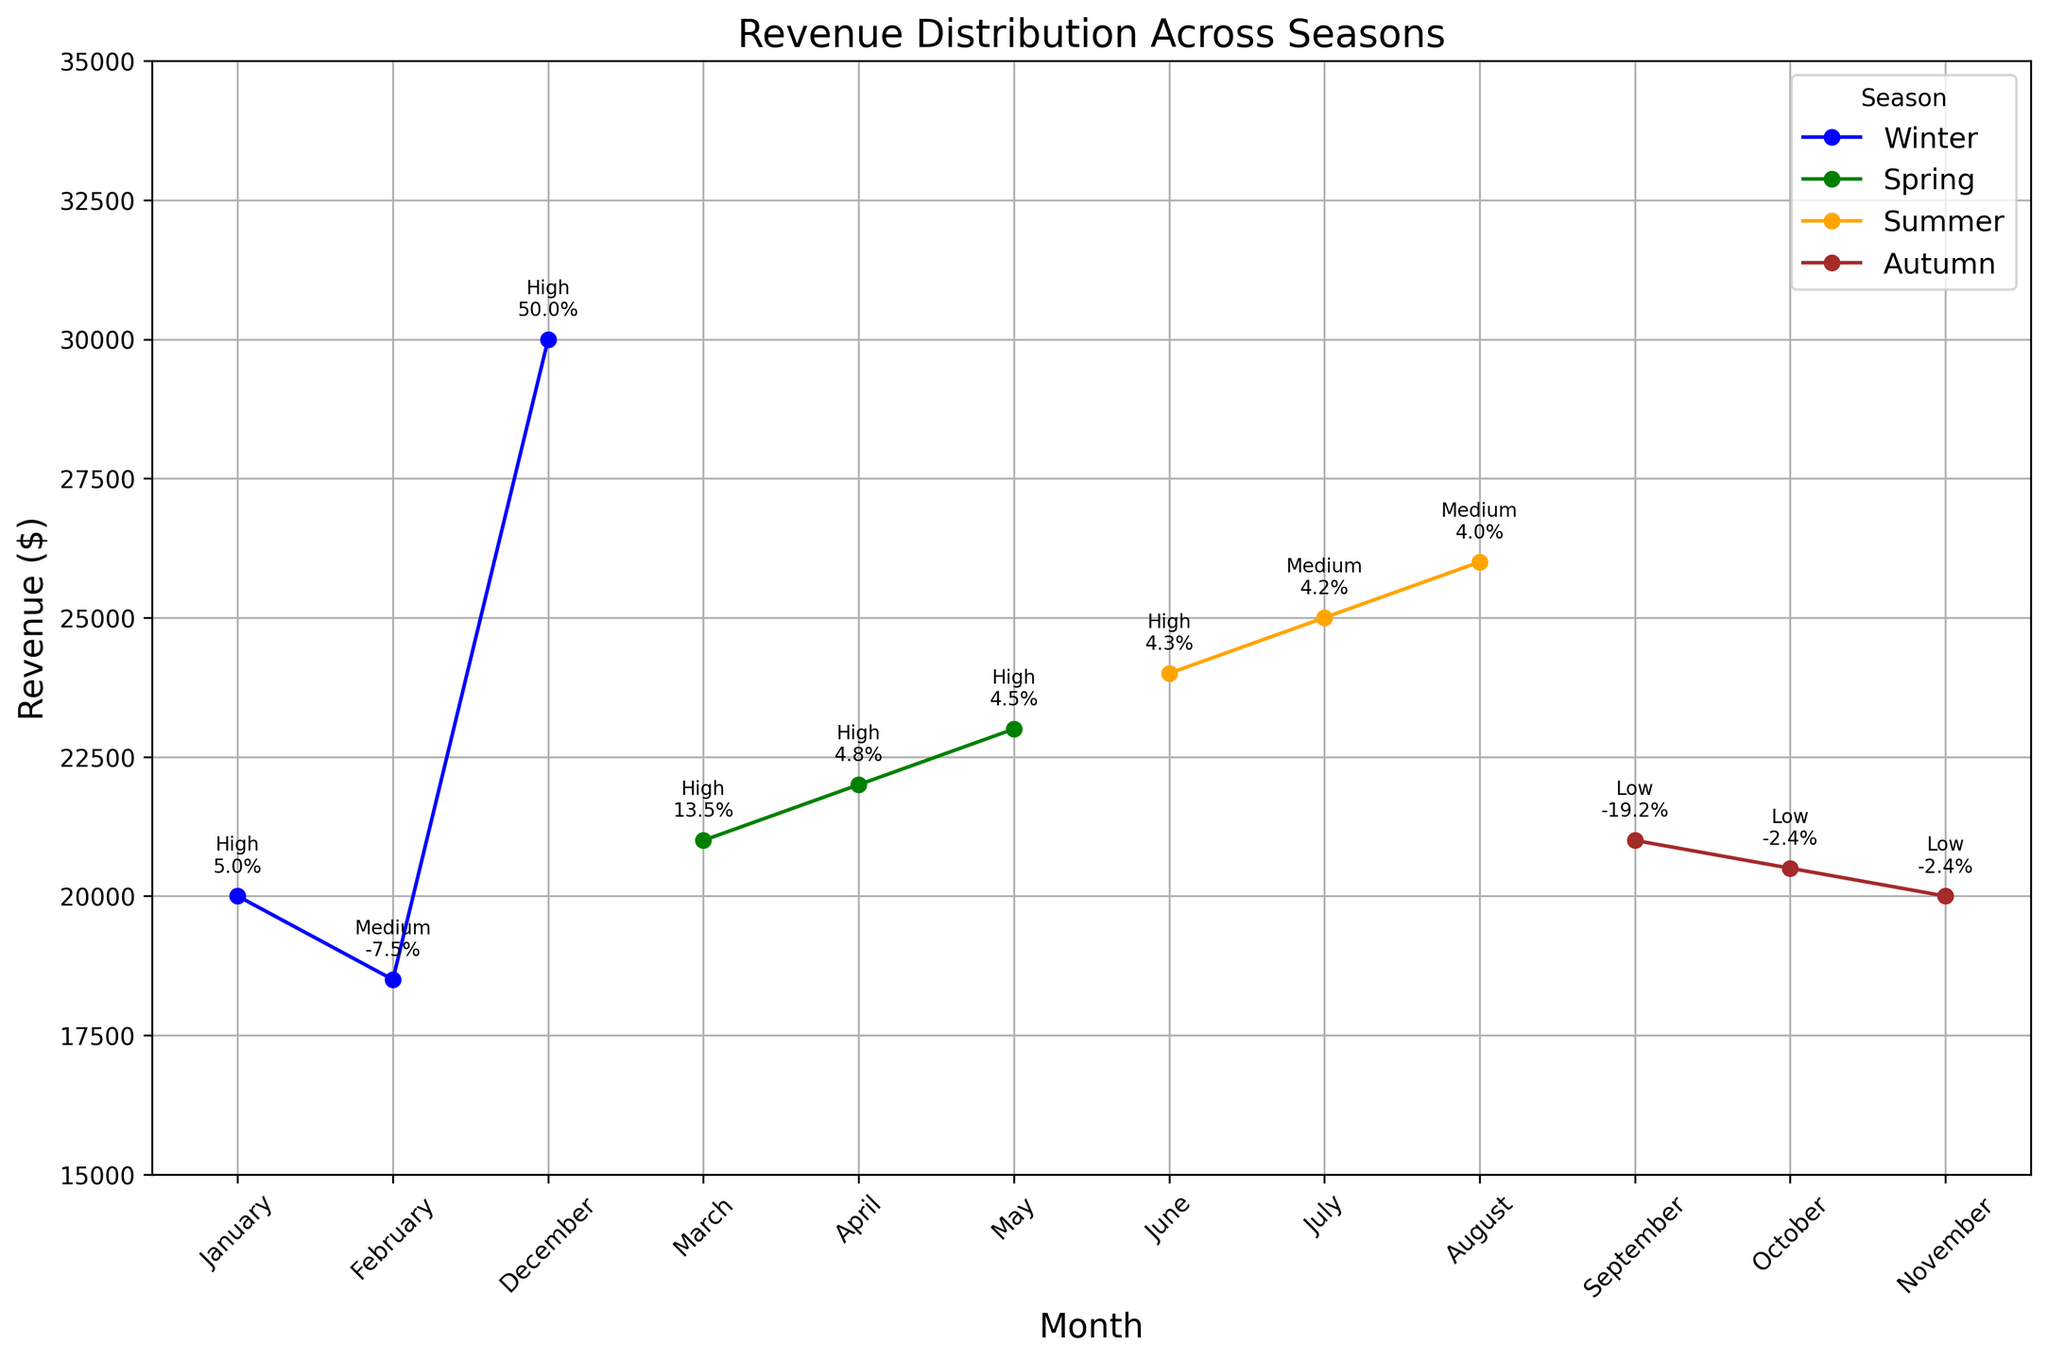What's the highest revenue recorded in any season? The highest revenue value can be found by looking at the peak of the plot. Refer to the annotations and read through the revenue values marked for each month. In December (Winter), the highest revenue of $30,000 is recorded.
Answer: $30,000 Which month experienced the highest revenue variation percentage? Check the variation percentages annotated on the plot for each month. The highest percentage of variation is in December which has a variation of 50%.
Answer: December During which season did the revenue decline the most compared to the previous month, and by how much? Identify the months with negative variation percentages and compare the absolute values to determine the largest decline. In Autumn, between August and September, the revenue dropped from $26,000 to $21,000 which is a decline of $5,000.
Answer: Autumn, $5,000 In which months were promotional campaigns most successful, and during which seasons do they occur? Look at the text annotations for "High" campaign success and note the corresponding months and seasons. Promotional campaigns were "High" in January, March, April, May, June, and December, which are in Winter, Spring, and Summer respectively.
Answer: Winter, Spring, Summer Compare the lowest revenue of Winter and Autumn. Which season recorded lower revenue and by how much? Identify the lowest revenue value in Winter and Autumn by checking the revenue values for those months. For Winter, the lowest revenue is $18,500 in February. For Autumn, the lowest is $20,000 in November. The difference is $20,000 - $18,500 = $1,500, with Winter being lower.
Answer: Winter, $1,500 How did the revenue vary across consecutive months in Autumn? Check the revenue values for September, October, and November in Autumn and observe the changes. Revenue in September is $21,000, in October it is $20,500, and in November it is $20,000. The revenue decreases each consecutive month.
Answer: Decreased consecutively Calculate the average revenue for each season and determine which season had the highest average. Sum the revenue values for each season and divide by the number of months in that season. For Winter: (20000+18500+30000)/3 = 22833.33; for Spring: (21000+22000+23000)/3 = 22000; for Summer (24000+25000+26000)/3 = 25000; for Autumn: (21000+20500+20000)/3 = 20500. The highest average revenue is in Summer.
Answer: Summer Which month within Spring had the lowest revenue variation percentage and what is that percentage? Look at the variation percentage annotations for March, April, and May. The lowest variation percentage in Spring is for May, with a percentage of 4.5%.
Answer: May, 4.5% Among months with "Low" campaign success, which month had the highest revenue, and what was it? Identify months annotated with "Low" campaign success, and compare their revenue values. September has the highest revenue among them, at $21,000.
Answer: September, $21,000 